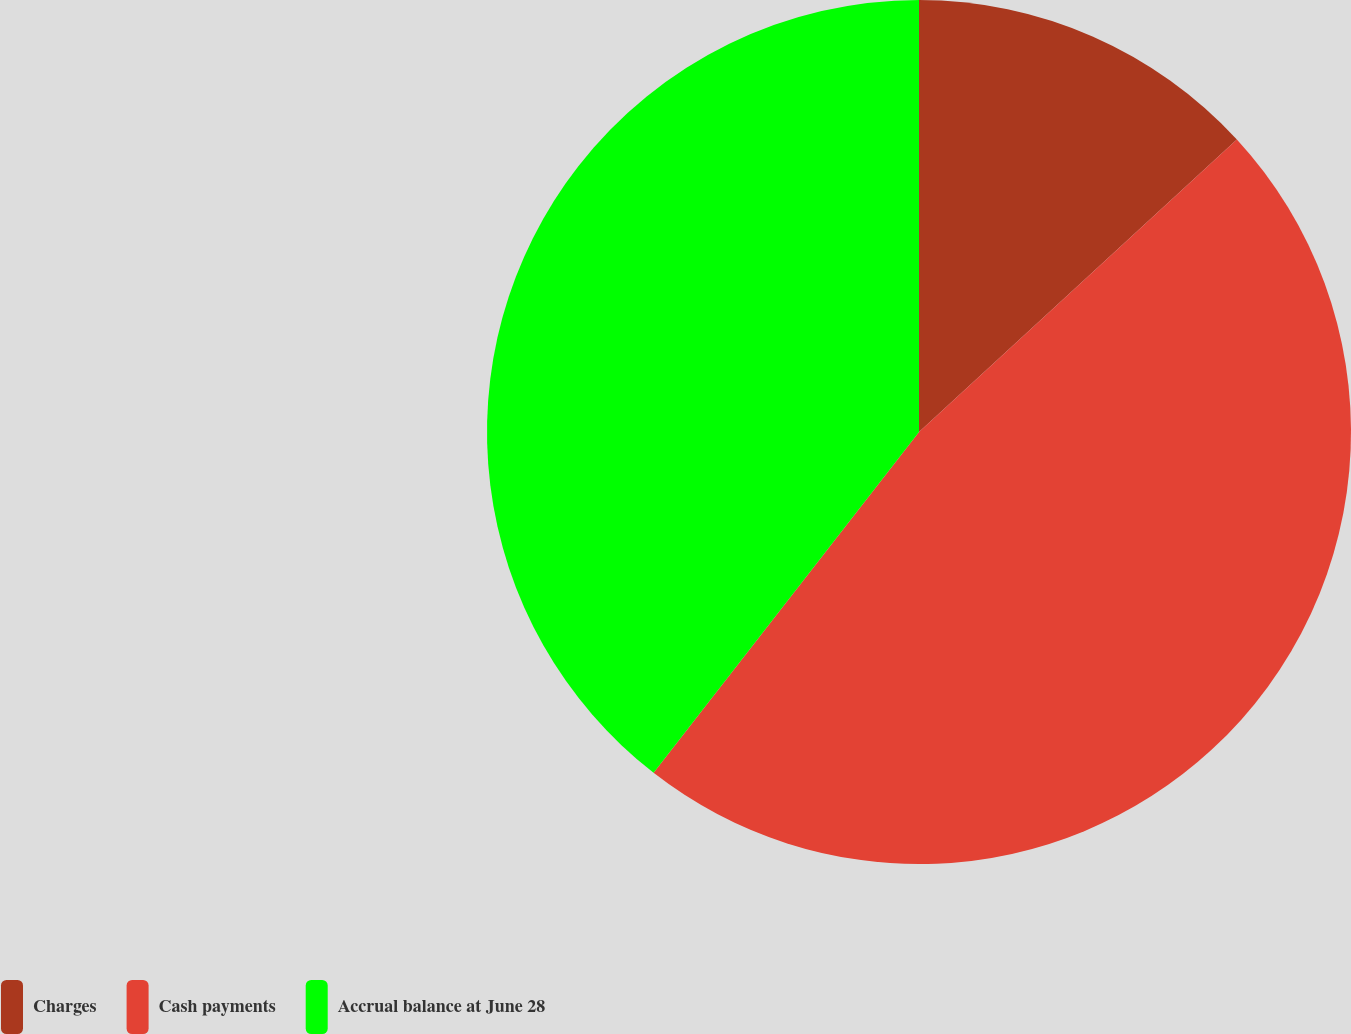Convert chart. <chart><loc_0><loc_0><loc_500><loc_500><pie_chart><fcel>Charges<fcel>Cash payments<fcel>Accrual balance at June 28<nl><fcel>13.16%<fcel>47.37%<fcel>39.47%<nl></chart> 